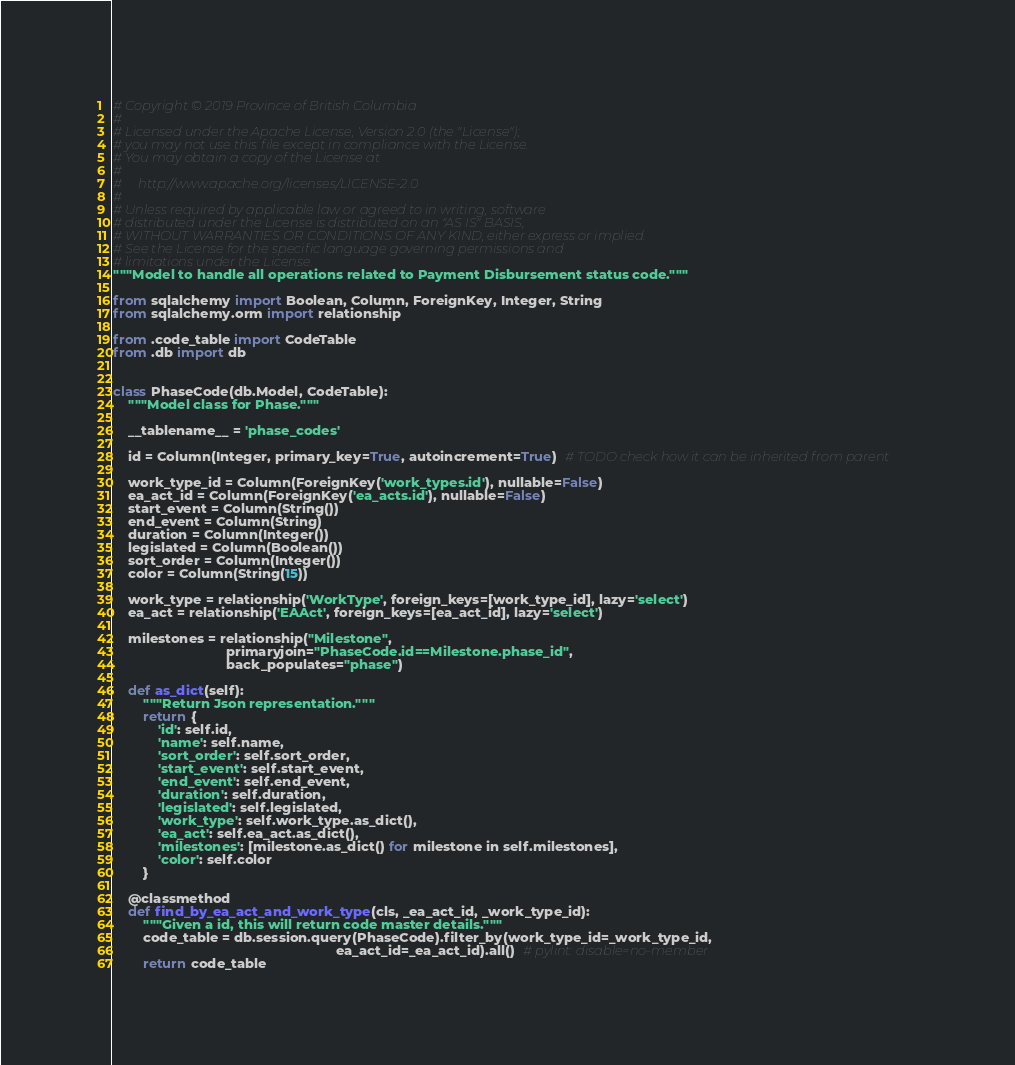Convert code to text. <code><loc_0><loc_0><loc_500><loc_500><_Python_># Copyright © 2019 Province of British Columbia
#
# Licensed under the Apache License, Version 2.0 (the "License");
# you may not use this file except in compliance with the License.
# You may obtain a copy of the License at
#
#     http://www.apache.org/licenses/LICENSE-2.0
#
# Unless required by applicable law or agreed to in writing, software
# distributed under the License is distributed on an "AS IS" BASIS,
# WITHOUT WARRANTIES OR CONDITIONS OF ANY KIND, either express or implied.
# See the License for the specific language governing permissions and
# limitations under the License.
"""Model to handle all operations related to Payment Disbursement status code."""

from sqlalchemy import Boolean, Column, ForeignKey, Integer, String
from sqlalchemy.orm import relationship

from .code_table import CodeTable
from .db import db


class PhaseCode(db.Model, CodeTable):
    """Model class for Phase."""

    __tablename__ = 'phase_codes'

    id = Column(Integer, primary_key=True, autoincrement=True)  # TODO check how it can be inherited from parent

    work_type_id = Column(ForeignKey('work_types.id'), nullable=False)
    ea_act_id = Column(ForeignKey('ea_acts.id'), nullable=False)
    start_event = Column(String())
    end_event = Column(String)
    duration = Column(Integer())
    legislated = Column(Boolean())
    sort_order = Column(Integer())
    color = Column(String(15))

    work_type = relationship('WorkType', foreign_keys=[work_type_id], lazy='select')
    ea_act = relationship('EAAct', foreign_keys=[ea_act_id], lazy='select')

    milestones = relationship("Milestone",
                              primaryjoin="PhaseCode.id==Milestone.phase_id",
                              back_populates="phase")

    def as_dict(self):
        """Return Json representation."""
        return {
            'id': self.id,
            'name': self.name,
            'sort_order': self.sort_order,
            'start_event': self.start_event,
            'end_event': self.end_event,
            'duration': self.duration,
            'legislated': self.legislated,
            'work_type': self.work_type.as_dict(),
            'ea_act': self.ea_act.as_dict(),
            'milestones': [milestone.as_dict() for milestone in self.milestones],
            'color': self.color
        }

    @classmethod
    def find_by_ea_act_and_work_type(cls, _ea_act_id, _work_type_id):
        """Given a id, this will return code master details."""
        code_table = db.session.query(PhaseCode).filter_by(work_type_id=_work_type_id,
                                                           ea_act_id=_ea_act_id).all()  # pylint: disable=no-member
        return code_table
</code> 